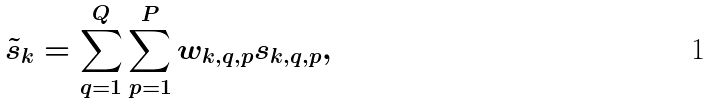Convert formula to latex. <formula><loc_0><loc_0><loc_500><loc_500>\tilde { s } _ { k } = \sum ^ { Q } _ { q = 1 } \sum ^ { P } _ { p = 1 } w _ { k , q , p } s _ { k , q , p } ,</formula> 